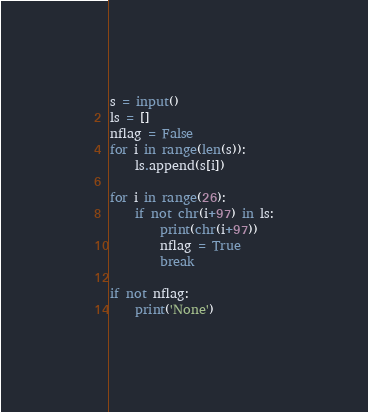<code> <loc_0><loc_0><loc_500><loc_500><_Python_>s = input()
ls = []
nflag = False
for i in range(len(s)):
    ls.append(s[i])

for i in range(26):
    if not chr(i+97) in ls:
        print(chr(i+97))
        nflag = True
        break

if not nflag:
    print('None')
</code> 